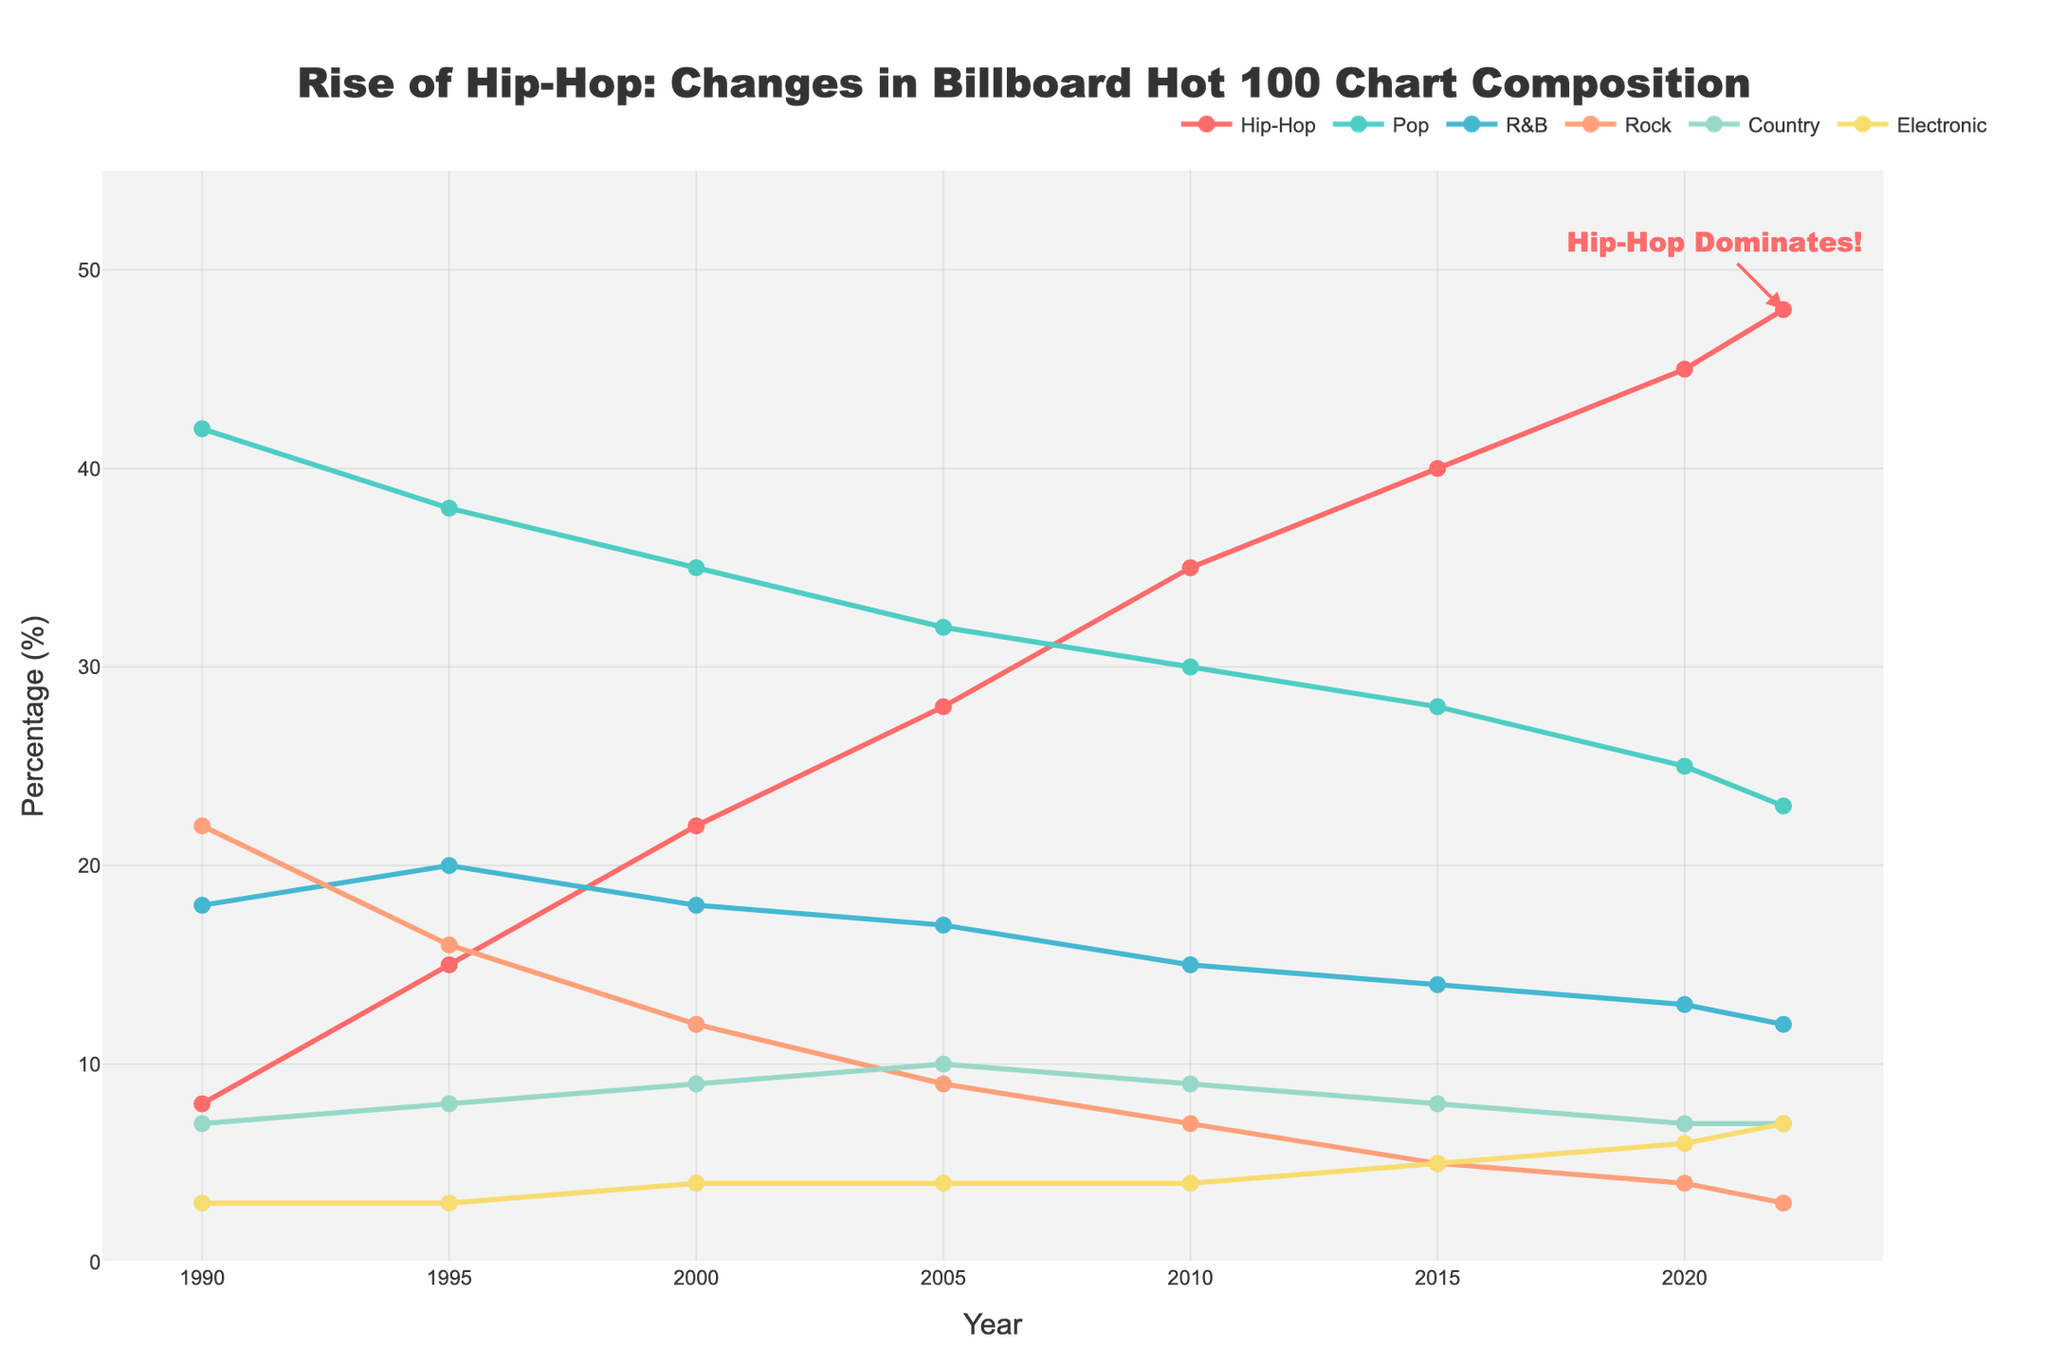Which year did hip-hop first surpass 20% in the Billboard Hot 100 chart? From the figure, we can see that hip-hop first reached over 20% in the year 2000.
Answer: 2000 How much did rock's presence decrease from 1990 to 2022? In 1990, rock's presence was 22%. By 2022, it had decreased to 3%. The difference is 22% - 3% = 19%.
Answer: 19% Which genres had a steady or increasing trend while rock declined over the years? By observing the trends over the years, hip-hop shows a clear steady increase, while electronic shows a slight increase.
Answer: Hip-hop, Electronic What is the highest percentage that hip-hop reached on the Billboard Hot 100 chart? The line representing hip-hop peaks at the highest point in the year 2022, with hip-hop reaching 48%.
Answer: 48% Compare the presence of hip-hop and country in 2022 and find the difference. In 2022, hip-hop is at 48% and country is at 7%. The difference is 48% - 7% = 41%.
Answer: 41% Has pop's presence increased or decreased from 1990 to 2022? From the figure, pop started at 42% in 1990 and decreased to 23% in 2022.
Answer: Decreased What year did hip-hop surpass pop on the Billboard chart? Hip-hop surpassed pop on the Billboard chart for the first time in 2015.
Answer: 2015 Describe the trend of electronic music from 1990 to 2022. The presence of electronic music gradually increased from 3% in 1990 to 7% in 2022.
Answer: Gradual Increase What is the combined percentage of hip-hop and R&B in 2010? In 2010, hip-hop's presence is 35% and R&B's presence is 15%. The combined percentage is 35% + 15% = 50%.
Answer: 50% 